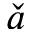<formula> <loc_0><loc_0><loc_500><loc_500>\check { a }</formula> 